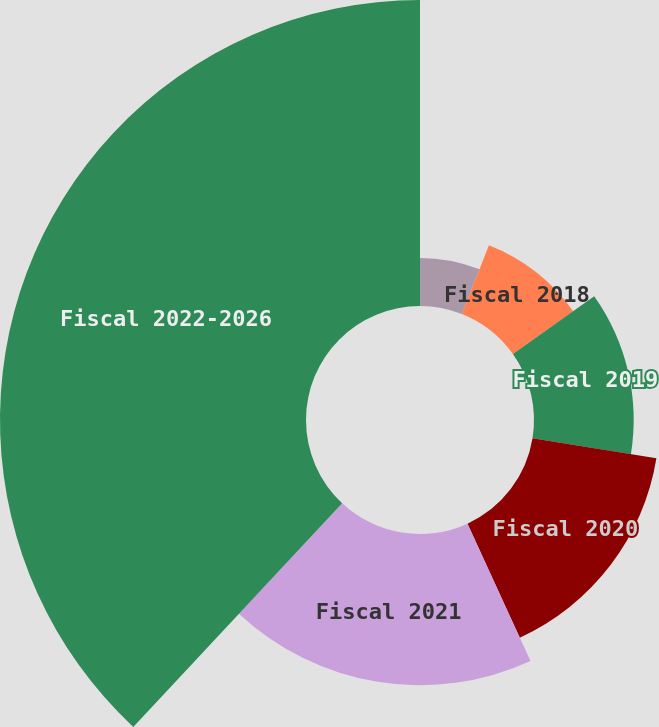<chart> <loc_0><loc_0><loc_500><loc_500><pie_chart><fcel>Fiscal 2017<fcel>Fiscal 2018<fcel>Fiscal 2019<fcel>Fiscal 2020<fcel>Fiscal 2021<fcel>Fiscal 2022-2026<nl><fcel>5.98%<fcel>9.19%<fcel>12.39%<fcel>15.6%<fcel>18.8%<fcel>38.04%<nl></chart> 